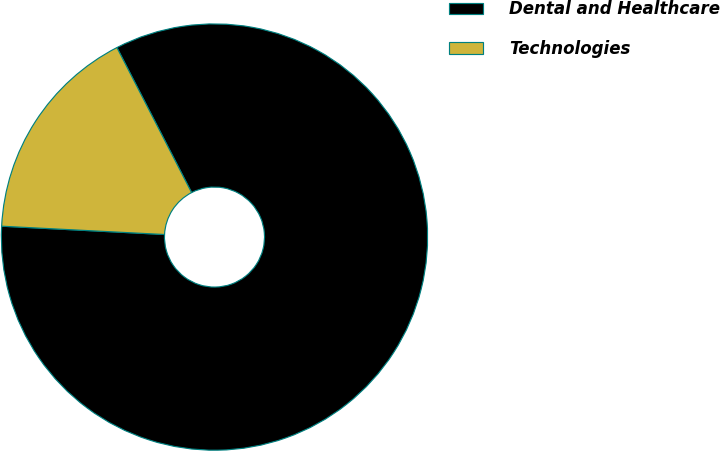Convert chart to OTSL. <chart><loc_0><loc_0><loc_500><loc_500><pie_chart><fcel>Dental and Healthcare<fcel>Technologies<nl><fcel>83.38%<fcel>16.62%<nl></chart> 